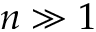Convert formula to latex. <formula><loc_0><loc_0><loc_500><loc_500>n \gg 1</formula> 